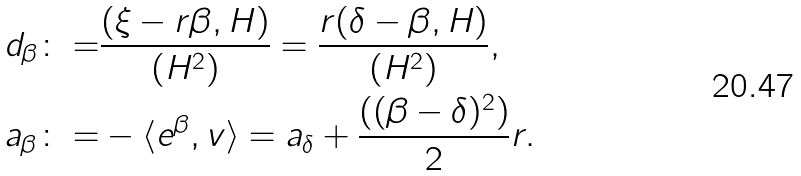<formula> <loc_0><loc_0><loc_500><loc_500>d _ { \beta } \colon = & \frac { ( \xi - r \beta , H ) } { ( H ^ { 2 } ) } = \frac { r ( \delta - \beta , H ) } { ( H ^ { 2 } ) } , \\ a _ { \beta } \colon = & - \langle e ^ { \beta } , v \rangle = a _ { \delta } + \frac { ( ( \beta - \delta ) ^ { 2 } ) } { 2 } r .</formula> 